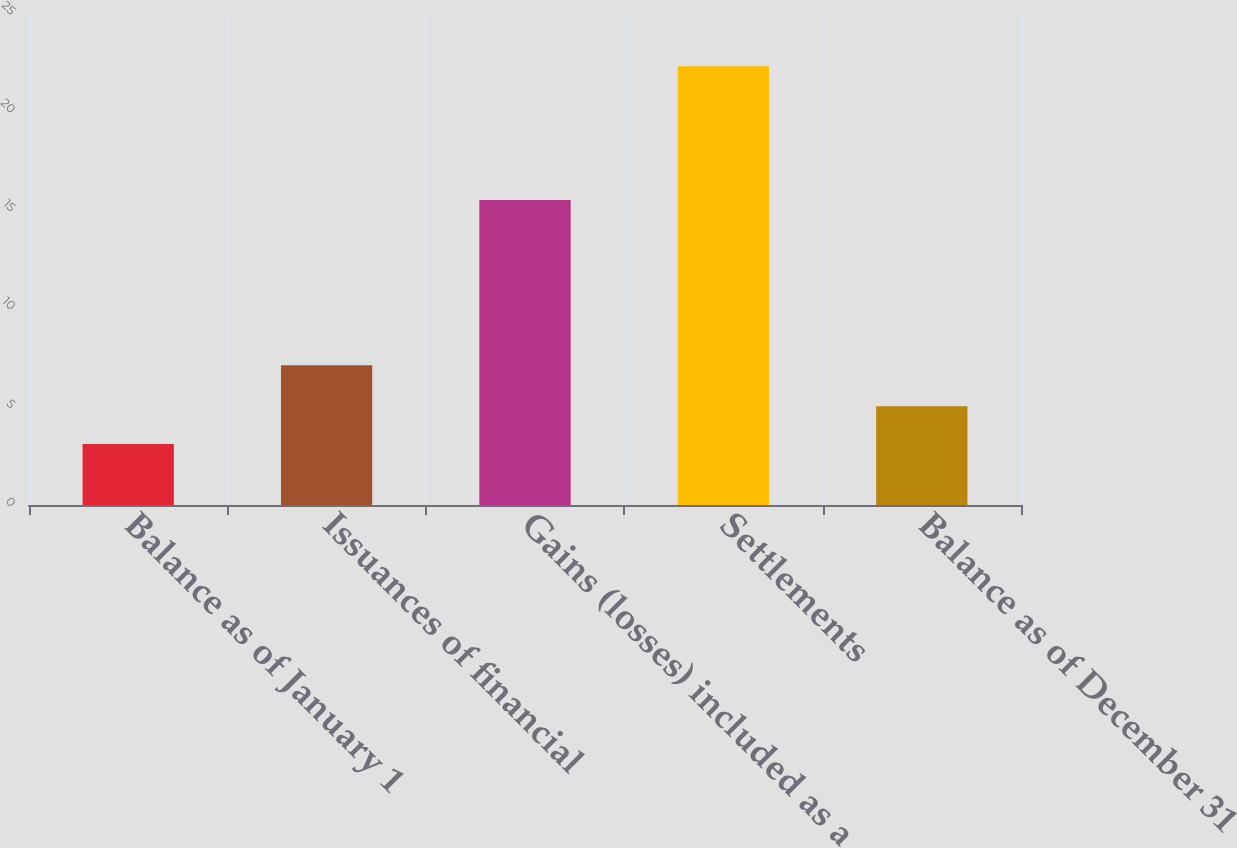<chart> <loc_0><loc_0><loc_500><loc_500><bar_chart><fcel>Balance as of January 1<fcel>Issuances of financial<fcel>Gains (losses) included as a<fcel>Settlements<fcel>Balance as of December 31<nl><fcel>3.1<fcel>7.1<fcel>15.5<fcel>22.3<fcel>5.02<nl></chart> 